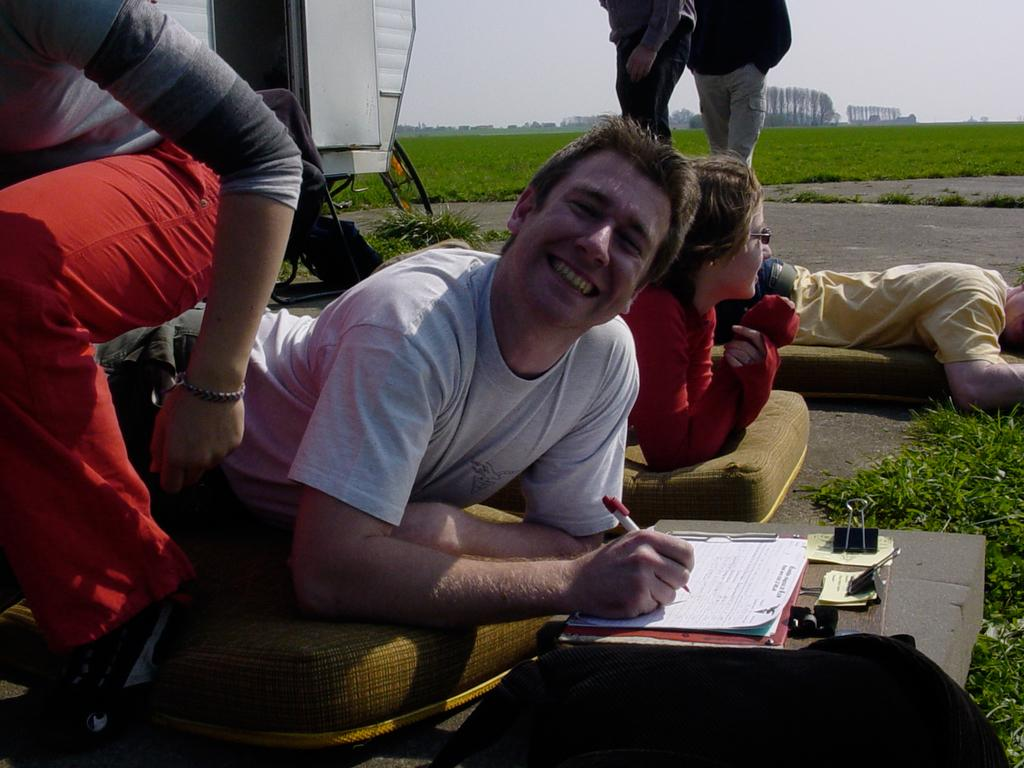How many people are in the image? There are people in the image, but the exact number is not specified. What is the man doing in the image? A man is smiling in the image, and he is holding a pen. What might the man be doing with the pen? The man might be writing or signing something, as he is holding a pen. What is the landscape like in the image? The land is covered with grass, and there are trees far away in the image. What type of stove can be seen in the image? There is no stove present in the image. Is there an airplane visible in the image? No, there is no airplane visible in the image. 